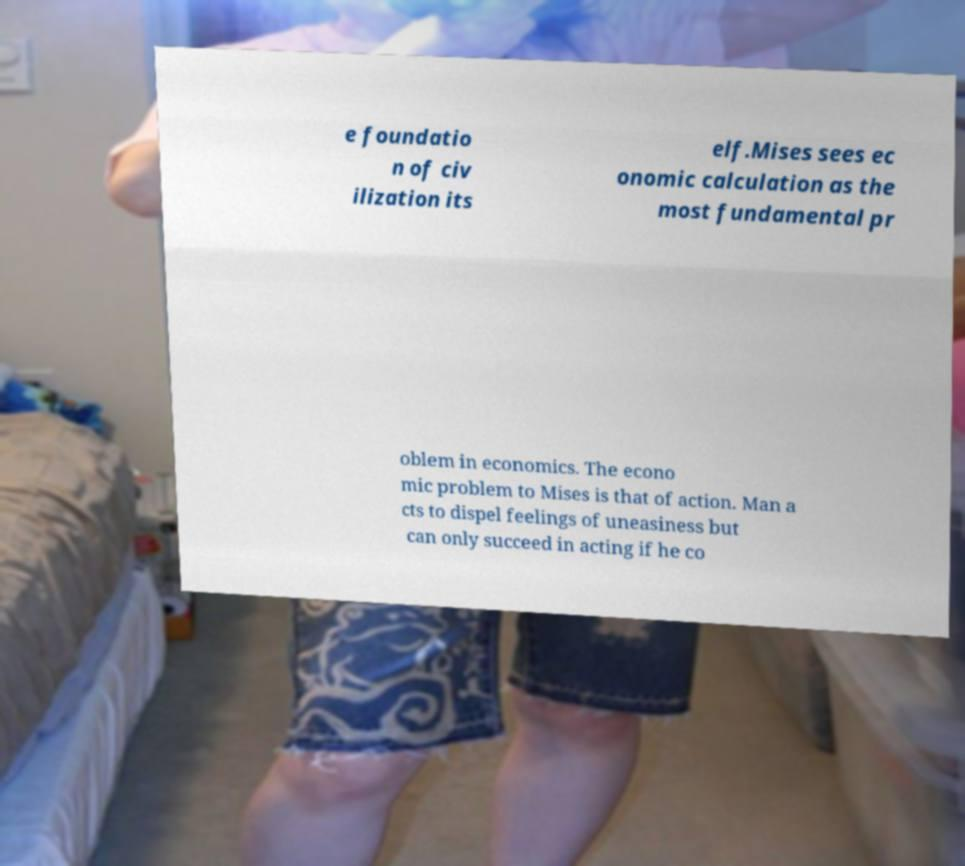What messages or text are displayed in this image? I need them in a readable, typed format. e foundatio n of civ ilization its elf.Mises sees ec onomic calculation as the most fundamental pr oblem in economics. The econo mic problem to Mises is that of action. Man a cts to dispel feelings of uneasiness but can only succeed in acting if he co 